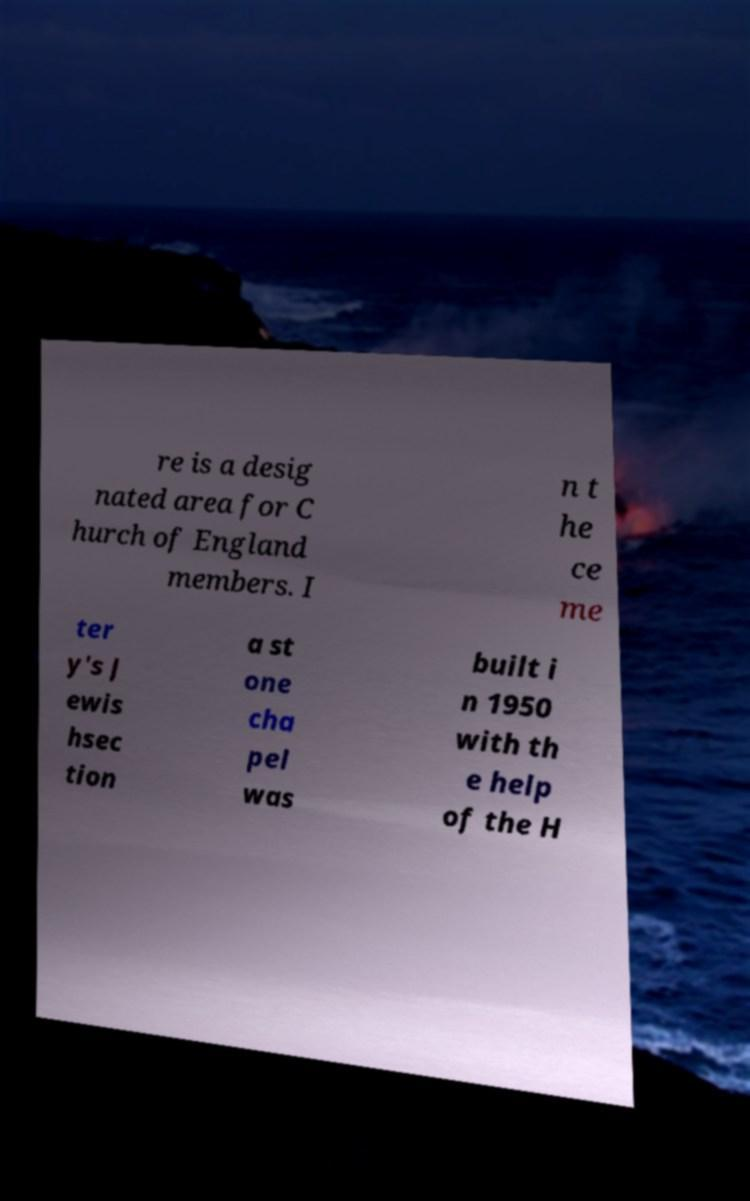Could you extract and type out the text from this image? re is a desig nated area for C hurch of England members. I n t he ce me ter y's J ewis hsec tion a st one cha pel was built i n 1950 with th e help of the H 